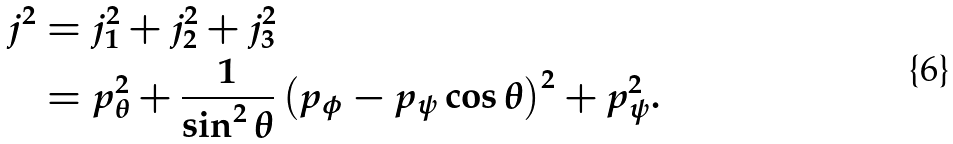Convert formula to latex. <formula><loc_0><loc_0><loc_500><loc_500>j ^ { 2 } & = j _ { 1 } ^ { 2 } + j _ { 2 } ^ { 2 } + j _ { 3 } ^ { 2 } \\ & = p _ { \theta } ^ { 2 } + \frac { 1 } { \sin ^ { 2 } \theta } \left ( p _ { \phi } - p _ { \psi } \cos \theta \right ) ^ { 2 } + p _ { \psi } ^ { 2 } .</formula> 